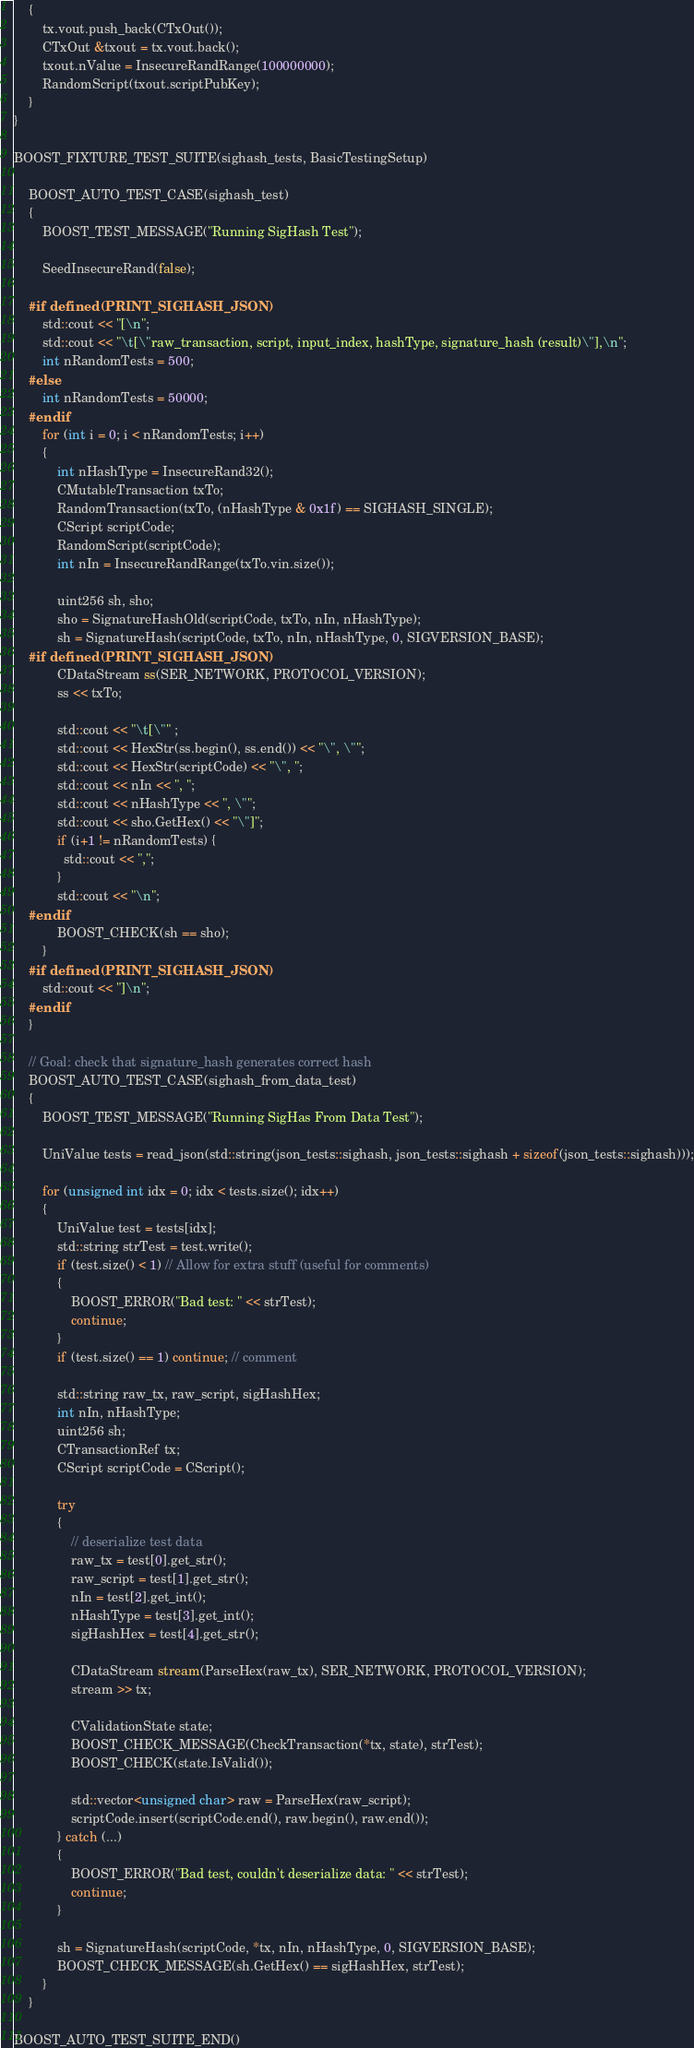<code> <loc_0><loc_0><loc_500><loc_500><_C++_>    {
        tx.vout.push_back(CTxOut());
        CTxOut &txout = tx.vout.back();
        txout.nValue = InsecureRandRange(100000000);
        RandomScript(txout.scriptPubKey);
    }
}

BOOST_FIXTURE_TEST_SUITE(sighash_tests, BasicTestingSetup)

    BOOST_AUTO_TEST_CASE(sighash_test)
    {
        BOOST_TEST_MESSAGE("Running SigHash Test");

        SeedInsecureRand(false);

    #if defined(PRINT_SIGHASH_JSON)
        std::cout << "[\n";
        std::cout << "\t[\"raw_transaction, script, input_index, hashType, signature_hash (result)\"],\n";
        int nRandomTests = 500;
    #else
        int nRandomTests = 50000;
    #endif
        for (int i = 0; i < nRandomTests; i++)
        {
            int nHashType = InsecureRand32();
            CMutableTransaction txTo;
            RandomTransaction(txTo, (nHashType & 0x1f) == SIGHASH_SINGLE);
            CScript scriptCode;
            RandomScript(scriptCode);
            int nIn = InsecureRandRange(txTo.vin.size());

            uint256 sh, sho;
            sho = SignatureHashOld(scriptCode, txTo, nIn, nHashType);
            sh = SignatureHash(scriptCode, txTo, nIn, nHashType, 0, SIGVERSION_BASE);
    #if defined(PRINT_SIGHASH_JSON)
            CDataStream ss(SER_NETWORK, PROTOCOL_VERSION);
            ss << txTo;

            std::cout << "\t[\"" ;
            std::cout << HexStr(ss.begin(), ss.end()) << "\", \"";
            std::cout << HexStr(scriptCode) << "\", ";
            std::cout << nIn << ", ";
            std::cout << nHashType << ", \"";
            std::cout << sho.GetHex() << "\"]";
            if (i+1 != nRandomTests) {
              std::cout << ",";
            }
            std::cout << "\n";
    #endif
            BOOST_CHECK(sh == sho);
        }
    #if defined(PRINT_SIGHASH_JSON)
        std::cout << "]\n";
    #endif
    }

    // Goal: check that signature_hash generates correct hash
    BOOST_AUTO_TEST_CASE(sighash_from_data_test)
    {
        BOOST_TEST_MESSAGE("Running SigHas From Data Test");

        UniValue tests = read_json(std::string(json_tests::sighash, json_tests::sighash + sizeof(json_tests::sighash)));

        for (unsigned int idx = 0; idx < tests.size(); idx++)
        {
            UniValue test = tests[idx];
            std::string strTest = test.write();
            if (test.size() < 1) // Allow for extra stuff (useful for comments)
            {
                BOOST_ERROR("Bad test: " << strTest);
                continue;
            }
            if (test.size() == 1) continue; // comment

            std::string raw_tx, raw_script, sigHashHex;
            int nIn, nHashType;
            uint256 sh;
            CTransactionRef tx;
            CScript scriptCode = CScript();

            try
            {
                // deserialize test data
                raw_tx = test[0].get_str();
                raw_script = test[1].get_str();
                nIn = test[2].get_int();
                nHashType = test[3].get_int();
                sigHashHex = test[4].get_str();

                CDataStream stream(ParseHex(raw_tx), SER_NETWORK, PROTOCOL_VERSION);
                stream >> tx;

                CValidationState state;
                BOOST_CHECK_MESSAGE(CheckTransaction(*tx, state), strTest);
                BOOST_CHECK(state.IsValid());

                std::vector<unsigned char> raw = ParseHex(raw_script);
                scriptCode.insert(scriptCode.end(), raw.begin(), raw.end());
            } catch (...)
            {
                BOOST_ERROR("Bad test, couldn't deserialize data: " << strTest);
                continue;
            }

            sh = SignatureHash(scriptCode, *tx, nIn, nHashType, 0, SIGVERSION_BASE);
            BOOST_CHECK_MESSAGE(sh.GetHex() == sigHashHex, strTest);
        }
    }

BOOST_AUTO_TEST_SUITE_END()
</code> 